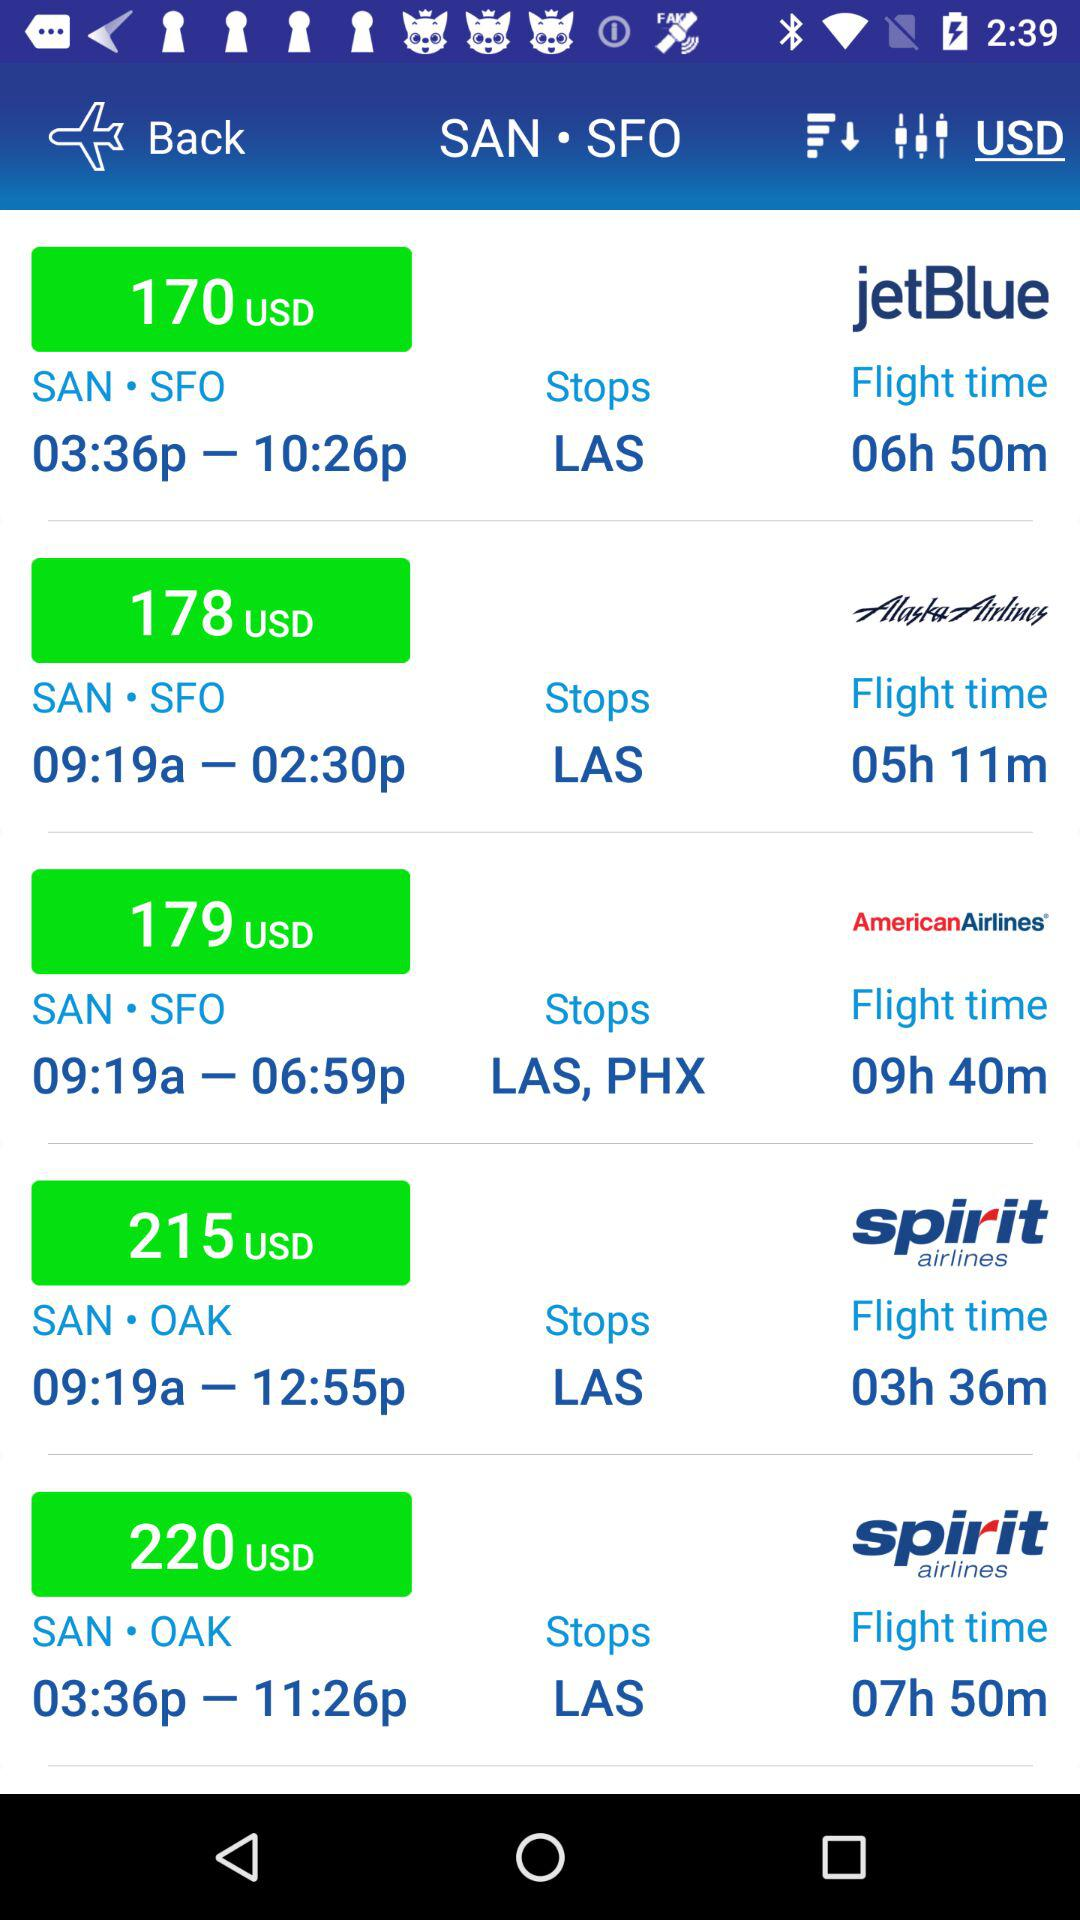At what station does JetBlue Airlines "Stops"? The station at which JetBlue Airlines "Stops" is LAS. 